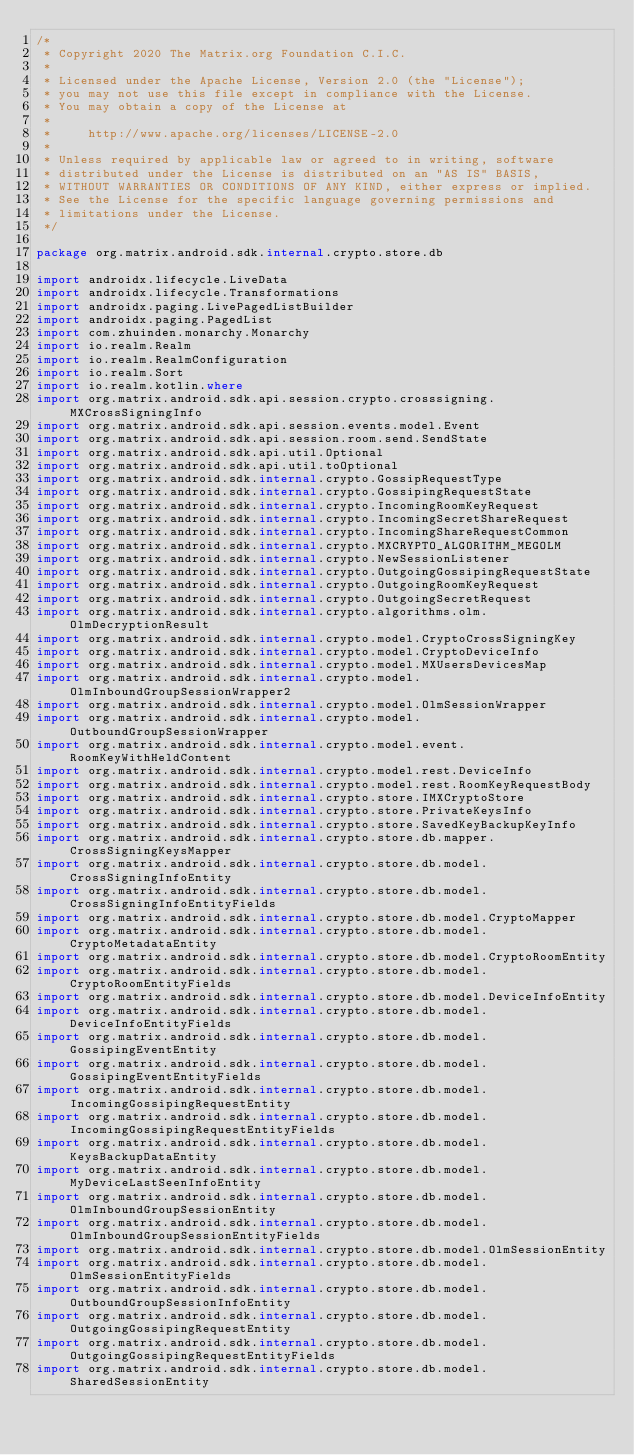<code> <loc_0><loc_0><loc_500><loc_500><_Kotlin_>/*
 * Copyright 2020 The Matrix.org Foundation C.I.C.
 *
 * Licensed under the Apache License, Version 2.0 (the "License");
 * you may not use this file except in compliance with the License.
 * You may obtain a copy of the License at
 *
 *     http://www.apache.org/licenses/LICENSE-2.0
 *
 * Unless required by applicable law or agreed to in writing, software
 * distributed under the License is distributed on an "AS IS" BASIS,
 * WITHOUT WARRANTIES OR CONDITIONS OF ANY KIND, either express or implied.
 * See the License for the specific language governing permissions and
 * limitations under the License.
 */

package org.matrix.android.sdk.internal.crypto.store.db

import androidx.lifecycle.LiveData
import androidx.lifecycle.Transformations
import androidx.paging.LivePagedListBuilder
import androidx.paging.PagedList
import com.zhuinden.monarchy.Monarchy
import io.realm.Realm
import io.realm.RealmConfiguration
import io.realm.Sort
import io.realm.kotlin.where
import org.matrix.android.sdk.api.session.crypto.crosssigning.MXCrossSigningInfo
import org.matrix.android.sdk.api.session.events.model.Event
import org.matrix.android.sdk.api.session.room.send.SendState
import org.matrix.android.sdk.api.util.Optional
import org.matrix.android.sdk.api.util.toOptional
import org.matrix.android.sdk.internal.crypto.GossipRequestType
import org.matrix.android.sdk.internal.crypto.GossipingRequestState
import org.matrix.android.sdk.internal.crypto.IncomingRoomKeyRequest
import org.matrix.android.sdk.internal.crypto.IncomingSecretShareRequest
import org.matrix.android.sdk.internal.crypto.IncomingShareRequestCommon
import org.matrix.android.sdk.internal.crypto.MXCRYPTO_ALGORITHM_MEGOLM
import org.matrix.android.sdk.internal.crypto.NewSessionListener
import org.matrix.android.sdk.internal.crypto.OutgoingGossipingRequestState
import org.matrix.android.sdk.internal.crypto.OutgoingRoomKeyRequest
import org.matrix.android.sdk.internal.crypto.OutgoingSecretRequest
import org.matrix.android.sdk.internal.crypto.algorithms.olm.OlmDecryptionResult
import org.matrix.android.sdk.internal.crypto.model.CryptoCrossSigningKey
import org.matrix.android.sdk.internal.crypto.model.CryptoDeviceInfo
import org.matrix.android.sdk.internal.crypto.model.MXUsersDevicesMap
import org.matrix.android.sdk.internal.crypto.model.OlmInboundGroupSessionWrapper2
import org.matrix.android.sdk.internal.crypto.model.OlmSessionWrapper
import org.matrix.android.sdk.internal.crypto.model.OutboundGroupSessionWrapper
import org.matrix.android.sdk.internal.crypto.model.event.RoomKeyWithHeldContent
import org.matrix.android.sdk.internal.crypto.model.rest.DeviceInfo
import org.matrix.android.sdk.internal.crypto.model.rest.RoomKeyRequestBody
import org.matrix.android.sdk.internal.crypto.store.IMXCryptoStore
import org.matrix.android.sdk.internal.crypto.store.PrivateKeysInfo
import org.matrix.android.sdk.internal.crypto.store.SavedKeyBackupKeyInfo
import org.matrix.android.sdk.internal.crypto.store.db.mapper.CrossSigningKeysMapper
import org.matrix.android.sdk.internal.crypto.store.db.model.CrossSigningInfoEntity
import org.matrix.android.sdk.internal.crypto.store.db.model.CrossSigningInfoEntityFields
import org.matrix.android.sdk.internal.crypto.store.db.model.CryptoMapper
import org.matrix.android.sdk.internal.crypto.store.db.model.CryptoMetadataEntity
import org.matrix.android.sdk.internal.crypto.store.db.model.CryptoRoomEntity
import org.matrix.android.sdk.internal.crypto.store.db.model.CryptoRoomEntityFields
import org.matrix.android.sdk.internal.crypto.store.db.model.DeviceInfoEntity
import org.matrix.android.sdk.internal.crypto.store.db.model.DeviceInfoEntityFields
import org.matrix.android.sdk.internal.crypto.store.db.model.GossipingEventEntity
import org.matrix.android.sdk.internal.crypto.store.db.model.GossipingEventEntityFields
import org.matrix.android.sdk.internal.crypto.store.db.model.IncomingGossipingRequestEntity
import org.matrix.android.sdk.internal.crypto.store.db.model.IncomingGossipingRequestEntityFields
import org.matrix.android.sdk.internal.crypto.store.db.model.KeysBackupDataEntity
import org.matrix.android.sdk.internal.crypto.store.db.model.MyDeviceLastSeenInfoEntity
import org.matrix.android.sdk.internal.crypto.store.db.model.OlmInboundGroupSessionEntity
import org.matrix.android.sdk.internal.crypto.store.db.model.OlmInboundGroupSessionEntityFields
import org.matrix.android.sdk.internal.crypto.store.db.model.OlmSessionEntity
import org.matrix.android.sdk.internal.crypto.store.db.model.OlmSessionEntityFields
import org.matrix.android.sdk.internal.crypto.store.db.model.OutboundGroupSessionInfoEntity
import org.matrix.android.sdk.internal.crypto.store.db.model.OutgoingGossipingRequestEntity
import org.matrix.android.sdk.internal.crypto.store.db.model.OutgoingGossipingRequestEntityFields
import org.matrix.android.sdk.internal.crypto.store.db.model.SharedSessionEntity</code> 